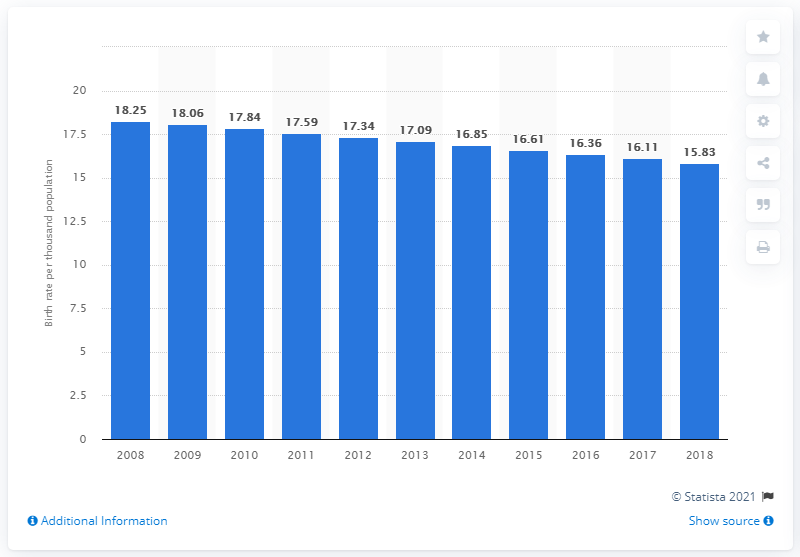List a handful of essential elements in this visual. In 2018, the crude birth rate in Sri Lanka was 15.83. 